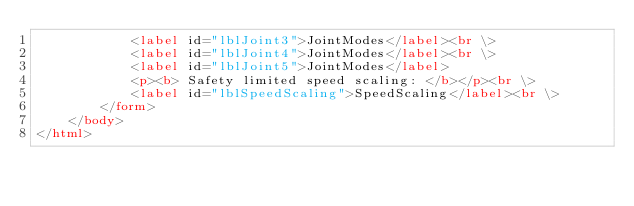Convert code to text. <code><loc_0><loc_0><loc_500><loc_500><_HTML_>			<label id="lblJoint3">JointModes</label><br \>
			<label id="lblJoint4">JointModes</label><br \>
			<label id="lblJoint5">JointModes</label>
			<p><b> Safety limited speed scaling: </b></p><br \>
			<label id="lblSpeedScaling">SpeedScaling</label><br \>
		</form>
	</body>
</html></code> 